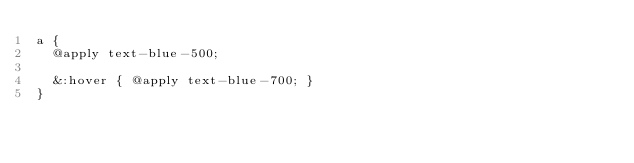Convert code to text. <code><loc_0><loc_0><loc_500><loc_500><_CSS_>a {
  @apply text-blue-500;

  &:hover { @apply text-blue-700; }
}
</code> 